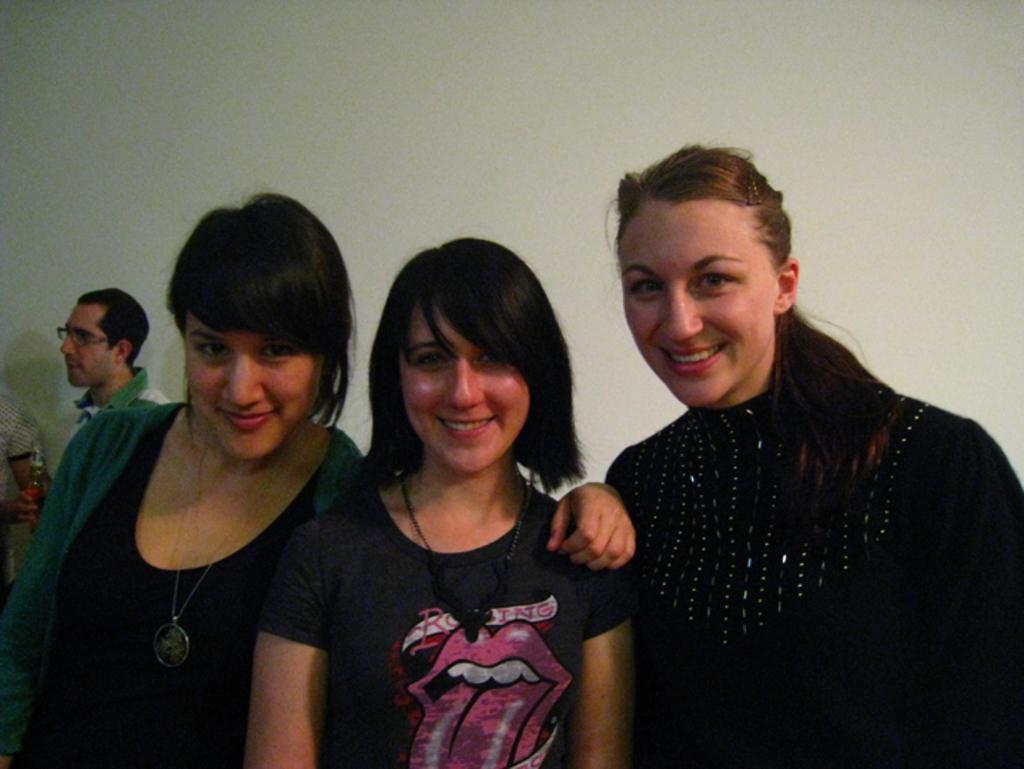In one or two sentences, can you explain what this image depicts? This picture is clicked inside. In the foreground we can see the three women wearing black color t-shirts, smiling and standing. In the background there is a wall. On the left we can see the two persons seems to be standing. 